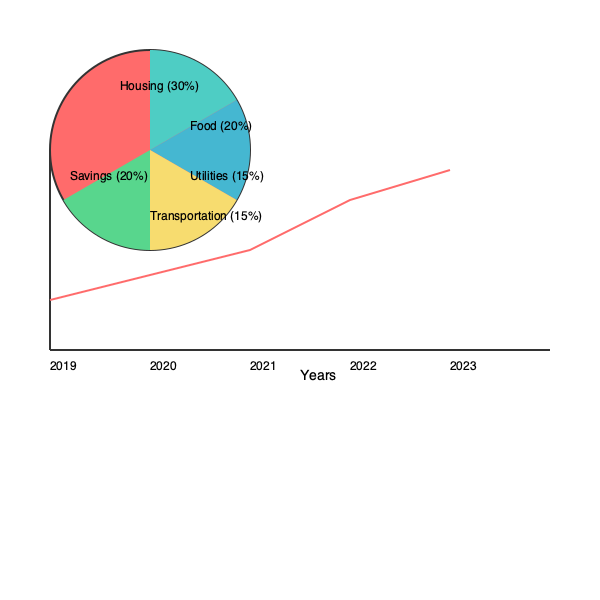Based on the household budget pie chart and savings trend graph provided, calculate the total amount saved over the 5-year period if the annual household income started at $50,000 in 2019 and increased by 3% each year. Assume the savings percentage remained constant throughout this period. To solve this problem, we'll follow these steps:

1. Calculate the household income for each year:
   2019: $50,000
   2020: $50,000 * 1.03 = $51,500
   2021: $51,500 * 1.03 = $53,045
   2022: $53,045 * 1.03 = $54,636.35
   2023: $54,636.35 * 1.03 = $56,275.44

2. Determine the savings percentage from the pie chart:
   The savings portion is 20% of the total budget.

3. Calculate the savings amount for each year:
   2019: $50,000 * 0.20 = $10,000
   2020: $51,500 * 0.20 = $10,300
   2021: $53,045 * 0.20 = $10,609
   2022: $54,636.35 * 0.20 = $10,927.27
   2023: $56,275.44 * 0.20 = $11,255.09

4. Sum up the total savings over the 5-year period:
   Total savings = $10,000 + $10,300 + $10,609 + $10,927.27 + $11,255.09
                 = $53,091.36

Therefore, the total amount saved over the 5-year period is approximately $53,091.36.
Answer: $53,091.36 